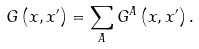Convert formula to latex. <formula><loc_0><loc_0><loc_500><loc_500>G \left ( x , x ^ { \prime } \right ) = \sum _ { A } G ^ { A } \left ( x , x ^ { \prime } \right ) .</formula> 